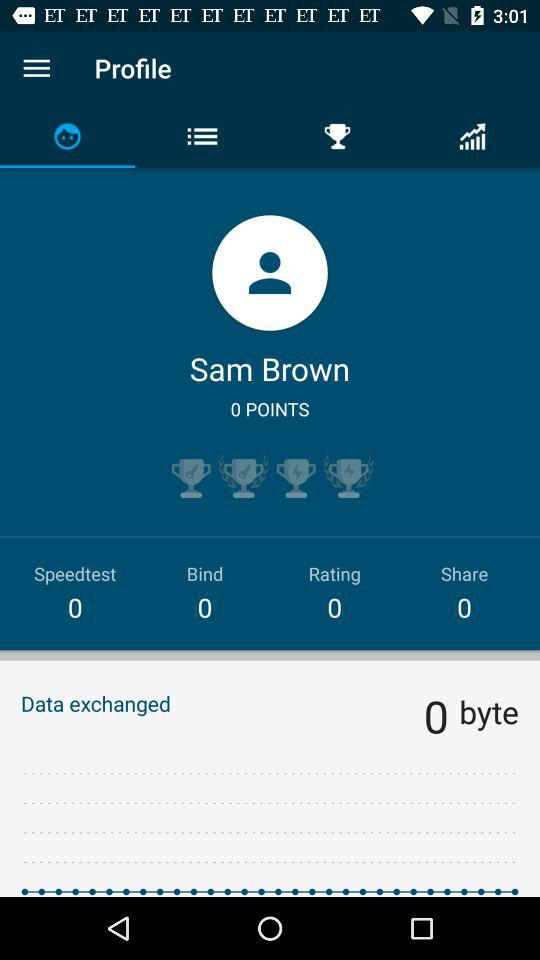How many trophies have Sam Brown earned?
Answer the question using a single word or phrase. 4 